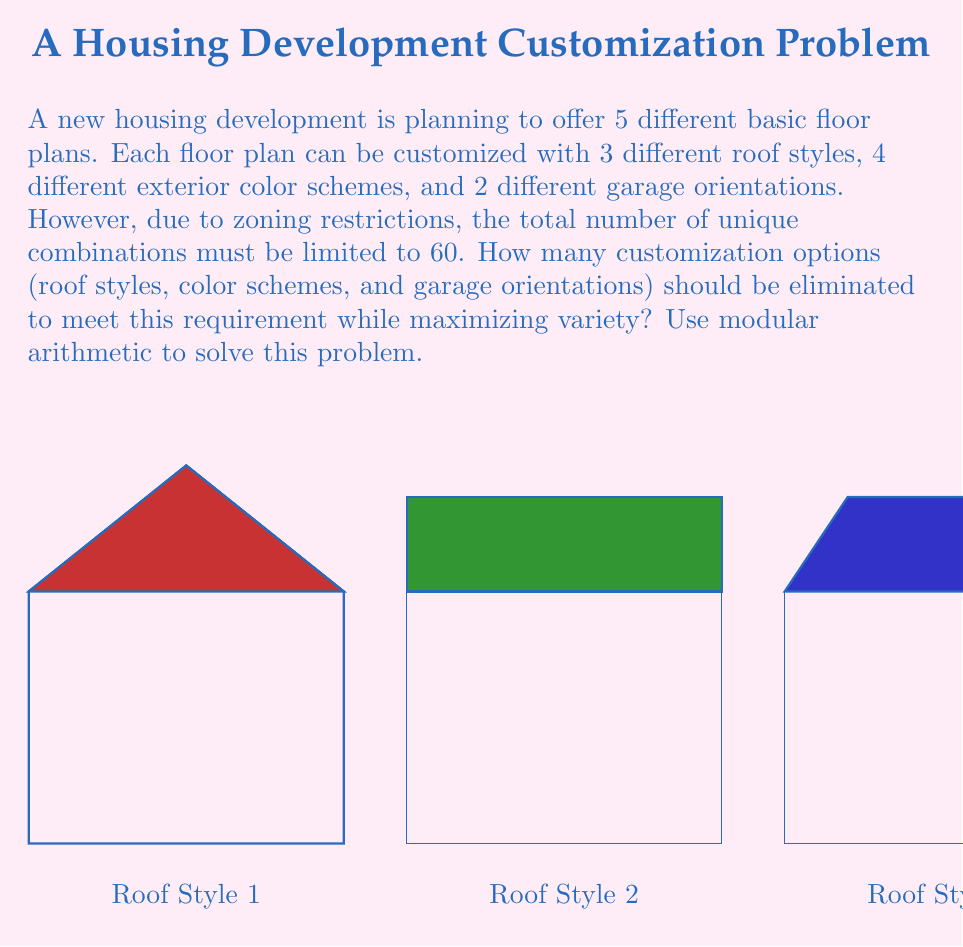Teach me how to tackle this problem. Let's approach this step-by-step using modular arithmetic:

1) Initially, the total number of combinations is:
   $5 \times 3 \times 4 \times 2 = 120$

2) We need to reduce this to 60. In modular arithmetic terms, we need:
   $120 \equiv 60 \pmod{x}$, where $x$ is the number of options we keep.

3) This is equivalent to:
   $60 \equiv 0 \pmod{x}$

4) The possible values for $x$ are the factors of 60:
   $60 = 2^2 \times 3 \times 5$
   Factors: 1, 2, 3, 4, 5, 6, 10, 12, 15, 20, 30, 60

5) To maximize variety, we want the largest $x$ that still meets our conditions.

6) $x = 30$ is the largest factor that works. This means we need to eliminate options to reduce the total from 120 to 90.

7) $120 - 90 = 30$ options need to be eliminated.

8) To determine which options to eliminate:
   - Roof styles: keep all 3 (3 options)
   - Exterior colors: keep all 4 (4 options)
   - Garage orientations: keep both 2 (2 options)
   - Floor plans: reduce from 5 to 3 (eliminate 2)

9) Checking: $3 \times 4 \times 2 \times 3 = 72$
   $72 \equiv 12 \pmod{30}$, which satisfies our condition.

Therefore, we should eliminate 2 floor plan options to meet the requirement while maximizing variety.
Answer: 2 floor plan options 